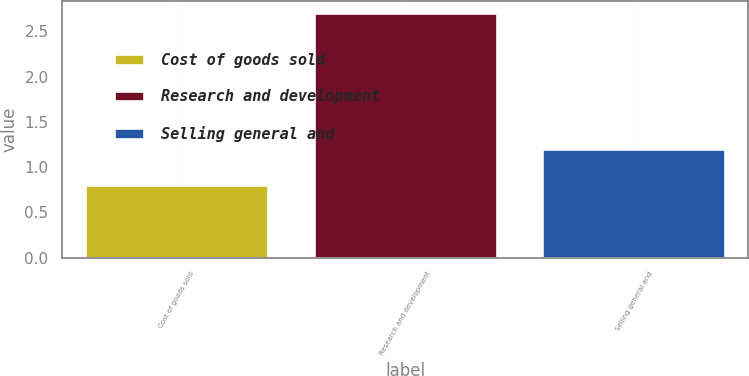Convert chart. <chart><loc_0><loc_0><loc_500><loc_500><bar_chart><fcel>Cost of goods sold<fcel>Research and development<fcel>Selling general and<nl><fcel>0.8<fcel>2.7<fcel>1.2<nl></chart> 